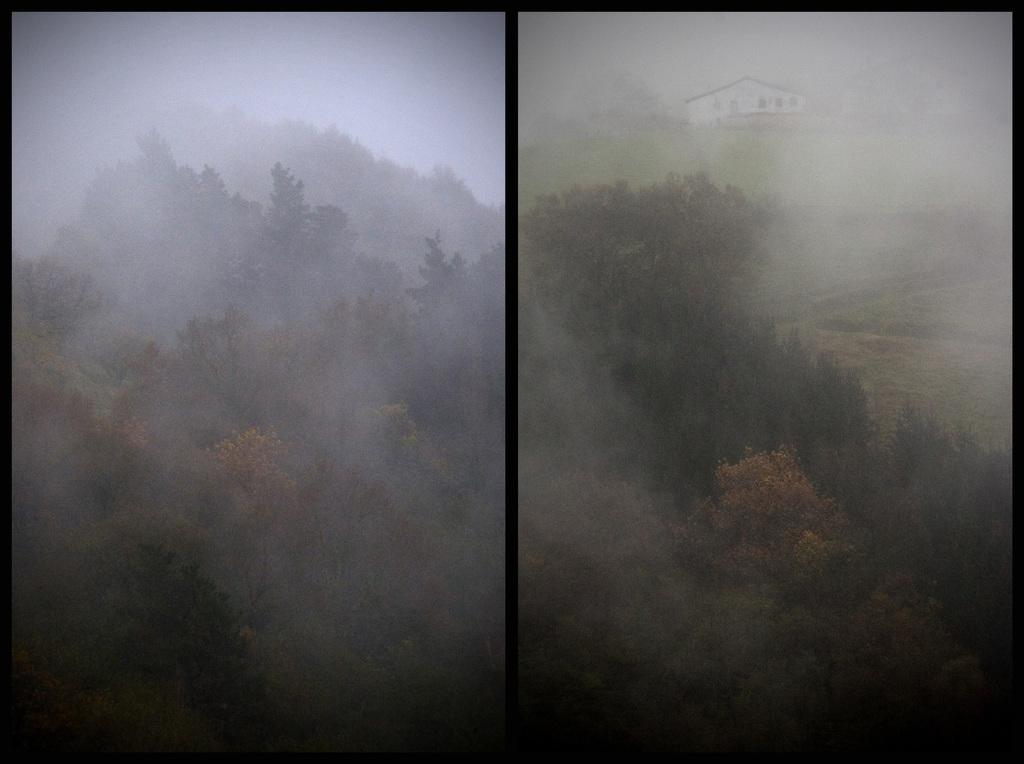Can you describe this image briefly? I see this is a collage of 2 pictures and I see number of trees and I see the smoke and I see a house over here. 